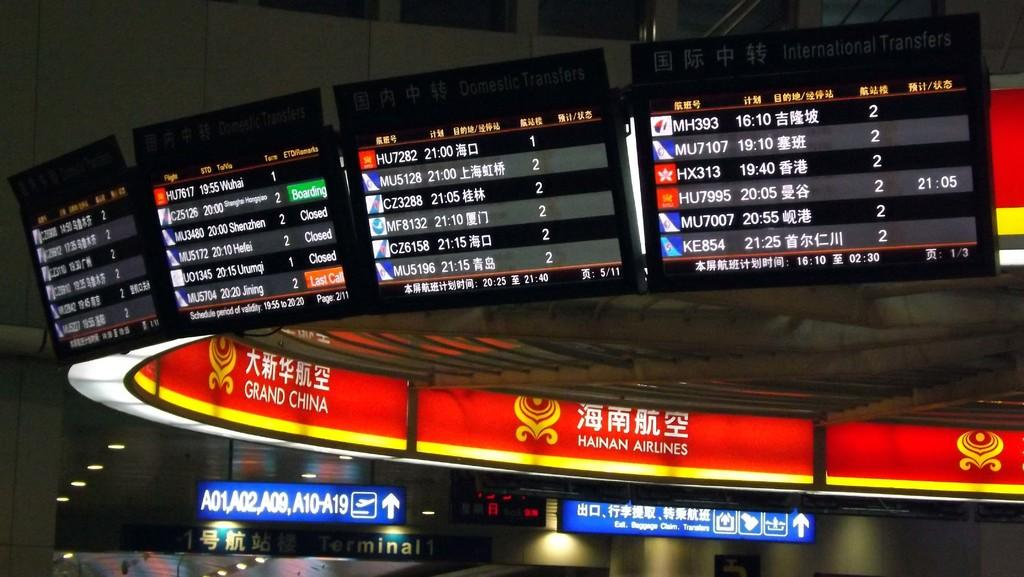<image>
Describe the image concisely. Flight departure and incoming boards show that several flights including HU7282 that is scheduled for 21:00 and MU5128 that is scheduled for 21:00. 